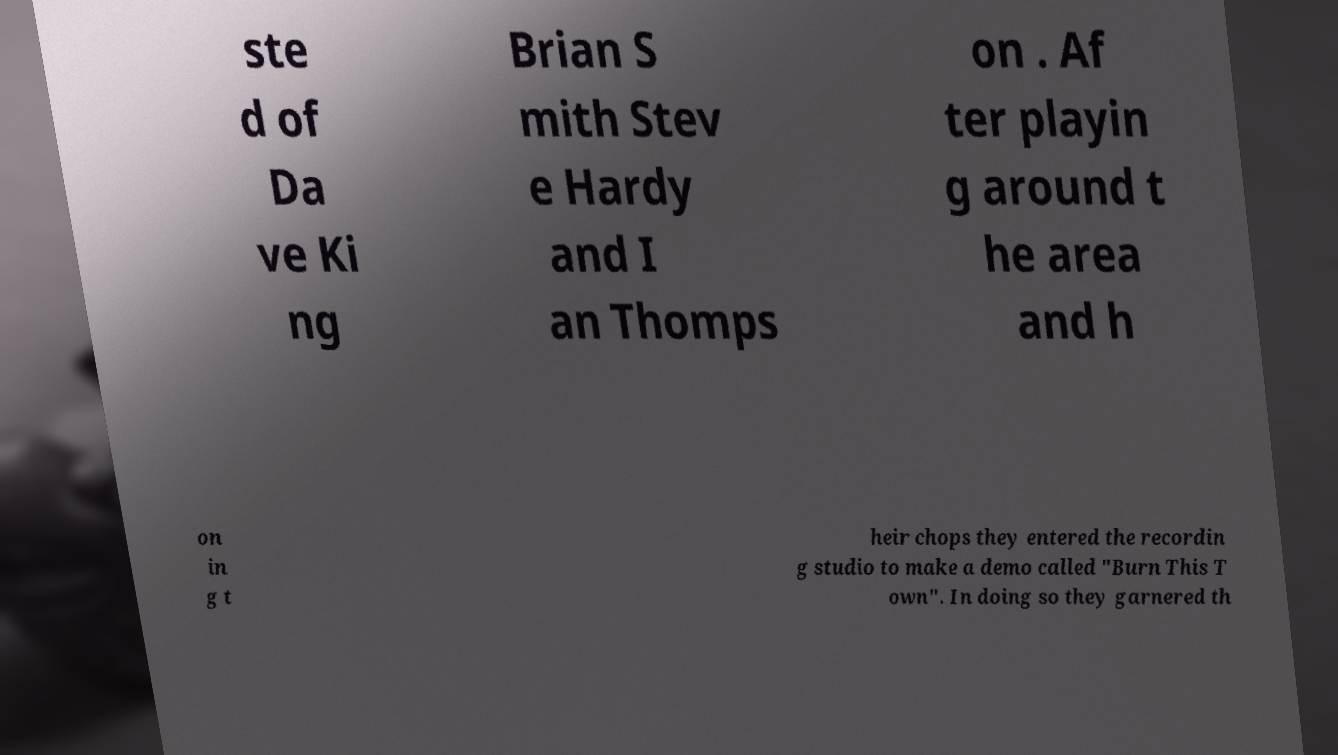Can you read and provide the text displayed in the image?This photo seems to have some interesting text. Can you extract and type it out for me? ste d of Da ve Ki ng Brian S mith Stev e Hardy and I an Thomps on . Af ter playin g around t he area and h on in g t heir chops they entered the recordin g studio to make a demo called "Burn This T own". In doing so they garnered th 